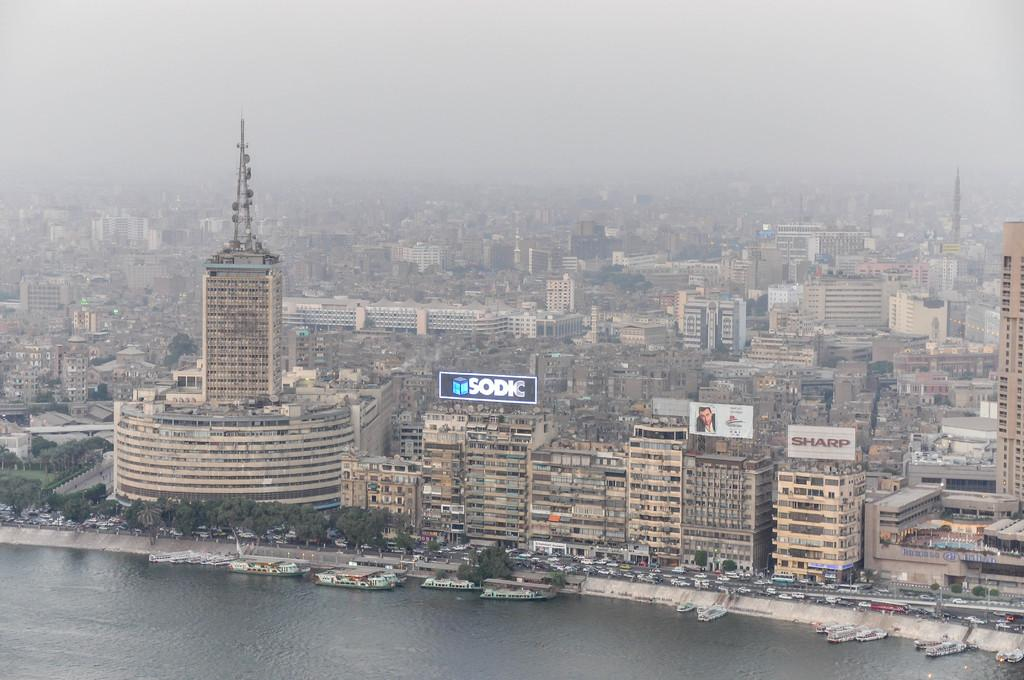What type of view is shown in the image? The image provides a view of the city from above. What can be seen in the foreground of the image? There are buildings in the front of the image. What is present near the bottom of the image? There is a river with white color boats in the front bottom side of the image. How many basketballs can be seen floating in the river in the image? There are no basketballs present in the image; it features a river with white color boats. 